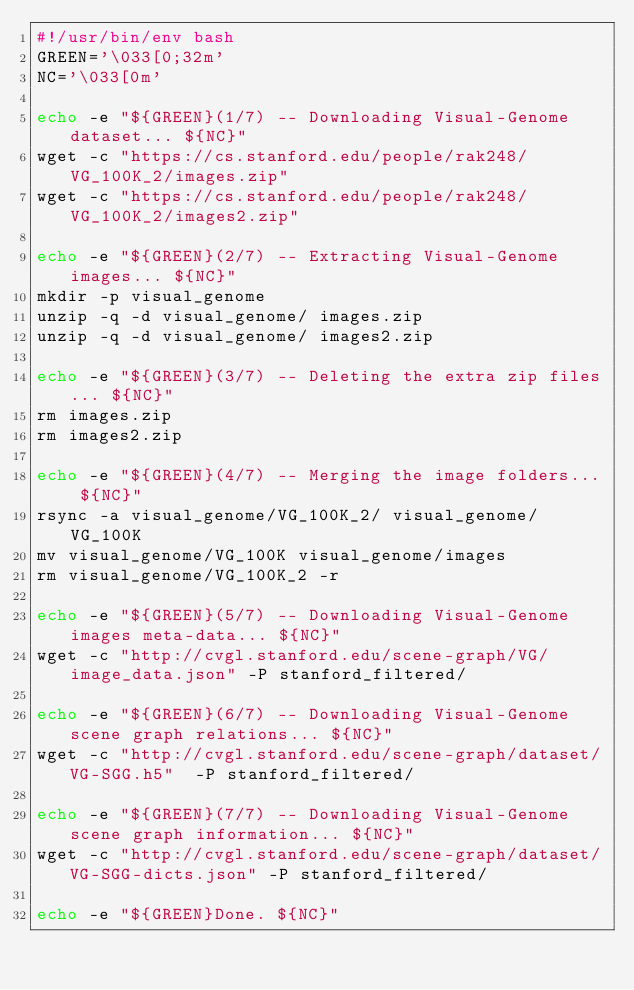<code> <loc_0><loc_0><loc_500><loc_500><_Bash_>#!/usr/bin/env bash
GREEN='\033[0;32m'
NC='\033[0m'

echo -e "${GREEN}(1/7) -- Downloading Visual-Genome dataset... ${NC}"
wget -c "https://cs.stanford.edu/people/rak248/VG_100K_2/images.zip"
wget -c "https://cs.stanford.edu/people/rak248/VG_100K_2/images2.zip"

echo -e "${GREEN}(2/7) -- Extracting Visual-Genome images... ${NC}"
mkdir -p visual_genome
unzip -q -d visual_genome/ images.zip
unzip -q -d visual_genome/ images2.zip

echo -e "${GREEN}(3/7) -- Deleting the extra zip files... ${NC}"
rm images.zip
rm images2.zip

echo -e "${GREEN}(4/7) -- Merging the image folders... ${NC}"
rsync -a visual_genome/VG_100K_2/ visual_genome/VG_100K
mv visual_genome/VG_100K visual_genome/images
rm visual_genome/VG_100K_2 -r

echo -e "${GREEN}(5/7) -- Downloading Visual-Genome images meta-data... ${NC}"
wget -c "http://cvgl.stanford.edu/scene-graph/VG/image_data.json" -P stanford_filtered/

echo -e "${GREEN}(6/7) -- Downloading Visual-Genome scene graph relations... ${NC}"
wget -c "http://cvgl.stanford.edu/scene-graph/dataset/VG-SGG.h5"  -P stanford_filtered/

echo -e "${GREEN}(7/7) -- Downloading Visual-Genome scene graph information... ${NC}"
wget -c "http://cvgl.stanford.edu/scene-graph/dataset/VG-SGG-dicts.json" -P stanford_filtered/

echo -e "${GREEN}Done. ${NC}"</code> 